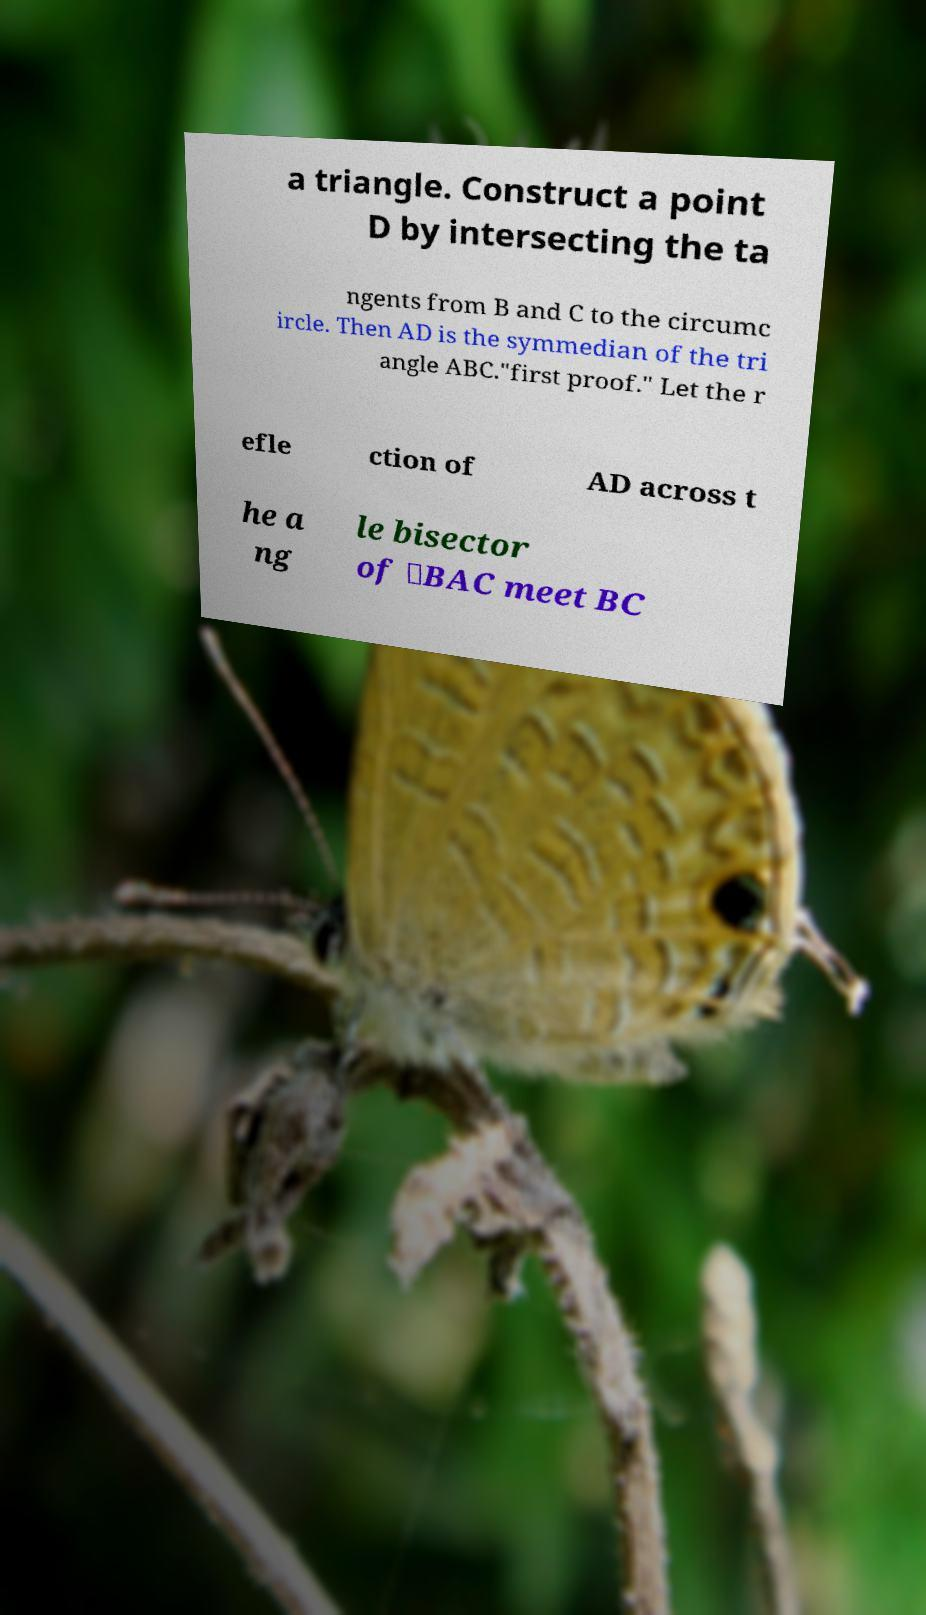For documentation purposes, I need the text within this image transcribed. Could you provide that? a triangle. Construct a point D by intersecting the ta ngents from B and C to the circumc ircle. Then AD is the symmedian of the tri angle ABC."first proof." Let the r efle ction of AD across t he a ng le bisector of ∠BAC meet BC 